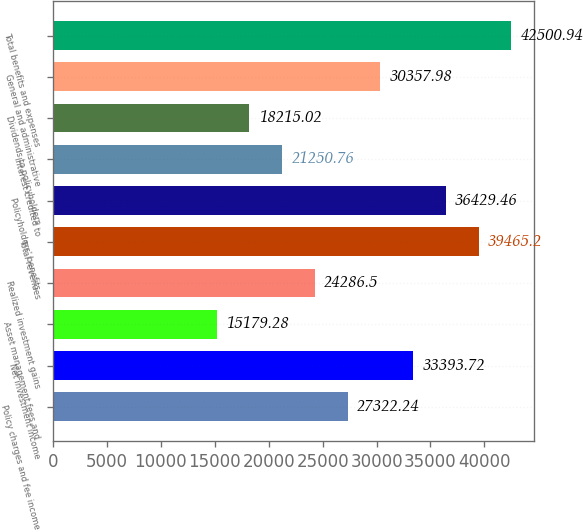Convert chart to OTSL. <chart><loc_0><loc_0><loc_500><loc_500><bar_chart><fcel>Policy charges and fee income<fcel>Net investment income<fcel>Asset management fees and<fcel>Realized investment gains<fcel>Total revenues<fcel>Policyholders' benefits<fcel>Interest credited to<fcel>Dividends to policyholders<fcel>General and administrative<fcel>Total benefits and expenses<nl><fcel>27322.2<fcel>33393.7<fcel>15179.3<fcel>24286.5<fcel>39465.2<fcel>36429.5<fcel>21250.8<fcel>18215<fcel>30358<fcel>42500.9<nl></chart> 